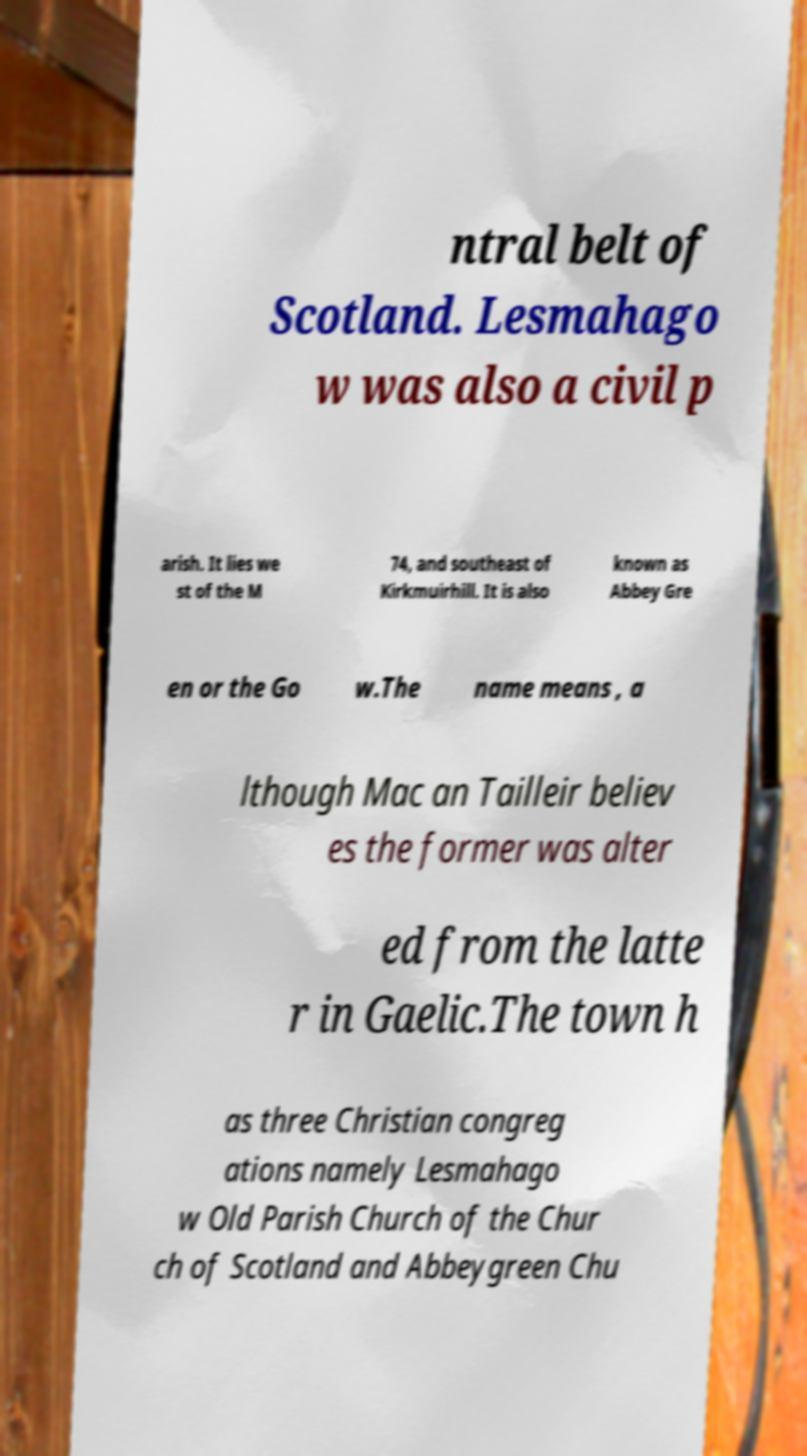Can you read and provide the text displayed in the image?This photo seems to have some interesting text. Can you extract and type it out for me? ntral belt of Scotland. Lesmahago w was also a civil p arish. It lies we st of the M 74, and southeast of Kirkmuirhill. It is also known as Abbey Gre en or the Go w.The name means , a lthough Mac an Tailleir believ es the former was alter ed from the latte r in Gaelic.The town h as three Christian congreg ations namely Lesmahago w Old Parish Church of the Chur ch of Scotland and Abbeygreen Chu 